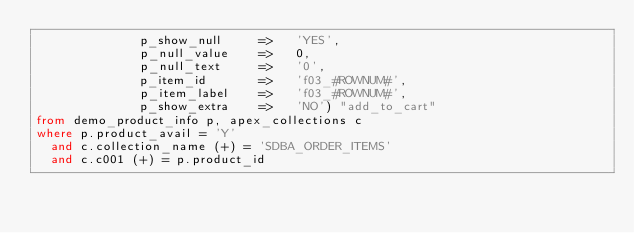Convert code to text. <code><loc_0><loc_0><loc_500><loc_500><_SQL_>              p_show_null     =>   'YES',
              p_null_value    =>   0,
              p_null_text     =>   '0',
              p_item_id       =>   'f03_#ROWNUM#',
              p_item_label    =>   'f03_#ROWNUM#',
              p_show_extra    =>   'NO') "add_to_cart"
from demo_product_info p, apex_collections c
where p.product_avail = 'Y'
  and c.collection_name (+) = 'SDBA_ORDER_ITEMS'
  and c.c001 (+) = p.product_id
</code> 